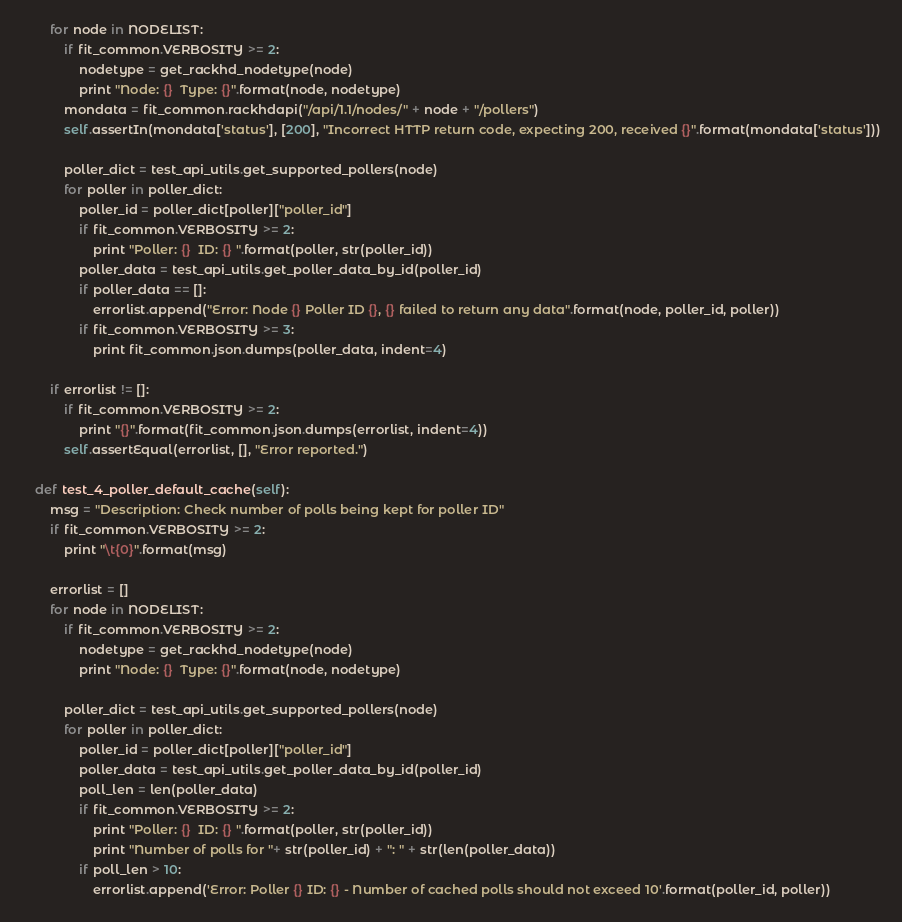Convert code to text. <code><loc_0><loc_0><loc_500><loc_500><_Python_>        for node in NODELIST:
            if fit_common.VERBOSITY >= 2:
                nodetype = get_rackhd_nodetype(node)
                print "Node: {}  Type: {}".format(node, nodetype)
            mondata = fit_common.rackhdapi("/api/1.1/nodes/" + node + "/pollers")
            self.assertIn(mondata['status'], [200], "Incorrect HTTP return code, expecting 200, received {}".format(mondata['status']))

            poller_dict = test_api_utils.get_supported_pollers(node)
            for poller in poller_dict:
                poller_id = poller_dict[poller]["poller_id"]
                if fit_common.VERBOSITY >= 2:
                    print "Poller: {}  ID: {} ".format(poller, str(poller_id))
                poller_data = test_api_utils.get_poller_data_by_id(poller_id)
                if poller_data == []:
                    errorlist.append("Error: Node {} Poller ID {}, {} failed to return any data".format(node, poller_id, poller))
                if fit_common.VERBOSITY >= 3:
                    print fit_common.json.dumps(poller_data, indent=4)

        if errorlist != []:
            if fit_common.VERBOSITY >= 2:
                print "{}".format(fit_common.json.dumps(errorlist, indent=4))
            self.assertEqual(errorlist, [], "Error reported.")

    def test_4_poller_default_cache(self):
        msg = "Description: Check number of polls being kept for poller ID"
        if fit_common.VERBOSITY >= 2:
            print "\t{0}".format(msg)

        errorlist = []
        for node in NODELIST:
            if fit_common.VERBOSITY >= 2:
                nodetype = get_rackhd_nodetype(node)
                print "Node: {}  Type: {}".format(node, nodetype)

            poller_dict = test_api_utils.get_supported_pollers(node)
            for poller in poller_dict:
                poller_id = poller_dict[poller]["poller_id"]
                poller_data = test_api_utils.get_poller_data_by_id(poller_id)
                poll_len = len(poller_data)
                if fit_common.VERBOSITY >= 2:
                    print "Poller: {}  ID: {} ".format(poller, str(poller_id))
                    print "Number of polls for "+ str(poller_id) + ": " + str(len(poller_data))
                if poll_len > 10:
                    errorlist.append('Error: Poller {} ID: {} - Number of cached polls should not exceed 10'.format(poller_id, poller))</code> 